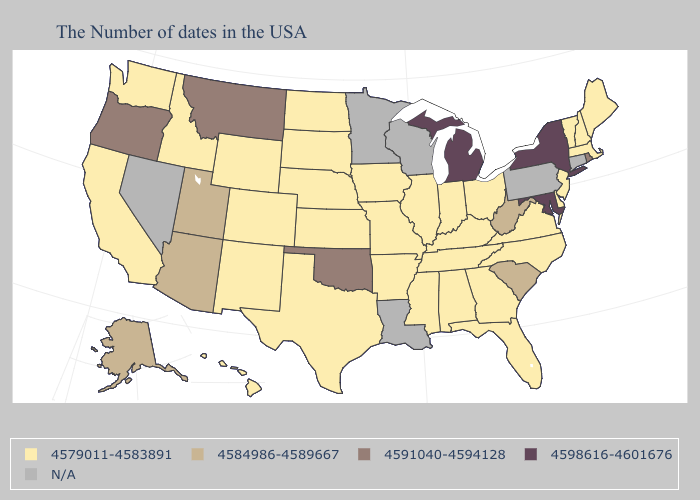What is the highest value in states that border Kentucky?
Concise answer only. 4584986-4589667. Name the states that have a value in the range 4584986-4589667?
Answer briefly. South Carolina, West Virginia, Utah, Arizona, Alaska. What is the value of South Carolina?
Concise answer only. 4584986-4589667. Among the states that border Maryland , does West Virginia have the lowest value?
Give a very brief answer. No. What is the value of North Carolina?
Write a very short answer. 4579011-4583891. What is the value of Utah?
Keep it brief. 4584986-4589667. What is the lowest value in the West?
Give a very brief answer. 4579011-4583891. Among the states that border Connecticut , which have the lowest value?
Be succinct. Massachusetts. Name the states that have a value in the range 4591040-4594128?
Write a very short answer. Rhode Island, Oklahoma, Montana, Oregon. What is the highest value in the USA?
Give a very brief answer. 4598616-4601676. Among the states that border Massachusetts , which have the lowest value?
Keep it brief. New Hampshire, Vermont. Name the states that have a value in the range N/A?
Short answer required. Connecticut, Pennsylvania, Wisconsin, Louisiana, Minnesota, Nevada. What is the lowest value in the USA?
Keep it brief. 4579011-4583891. 